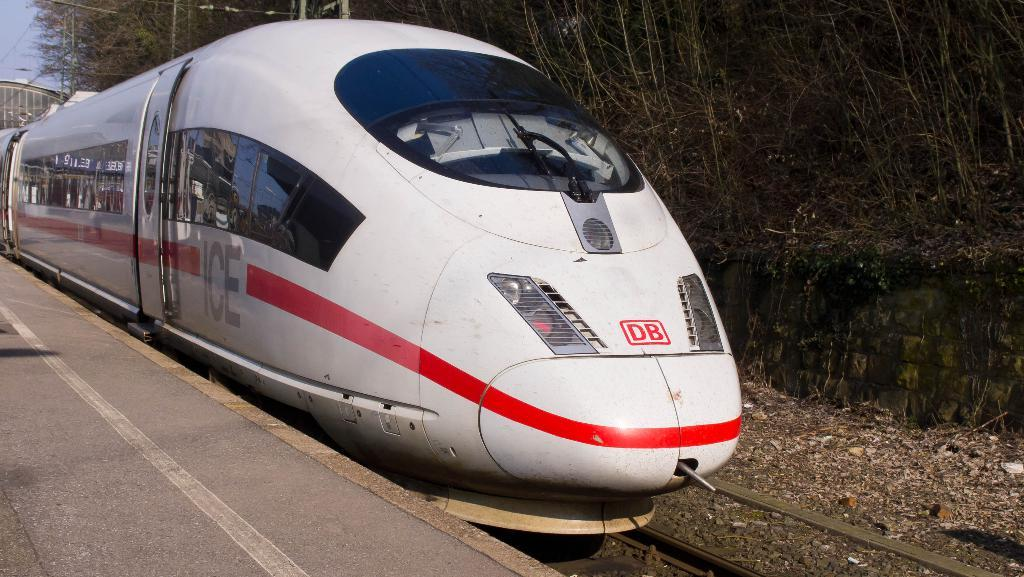What is the main subject of the image? The main subject of the image is a train. Can you describe the color of the train? The train is white in color. What can be seen in the background of the image? The sky, trees, and a railway track are visible in the background of the image. What time does the clock on the train show in the image? There is no clock present on the train in the image. Can you describe the breath of the train in the image? Trains do not have breath, as they are inanimate objects. 